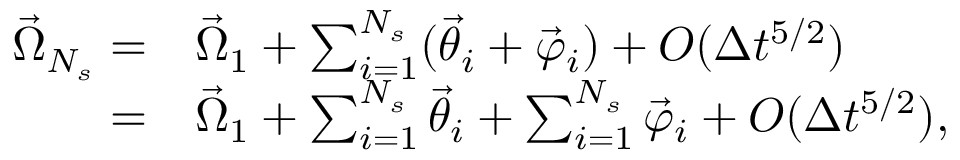Convert formula to latex. <formula><loc_0><loc_0><loc_500><loc_500>\begin{array} { r l } { \vec { \Omega } _ { N _ { s } } = } & { \vec { \Omega } _ { 1 } + \sum _ { i = 1 } ^ { N _ { s } } ( \vec { \theta } _ { i } + \vec { \varphi } _ { i } ) + O ( \Delta t ^ { 5 / 2 } ) } \\ { = } & { \vec { \Omega } _ { 1 } + \sum _ { i = 1 } ^ { N _ { s } } \vec { \theta } _ { i } + \sum _ { i = 1 } ^ { N _ { s } } \vec { \varphi } _ { i } + O ( \Delta t ^ { 5 / 2 } ) , } \end{array}</formula> 